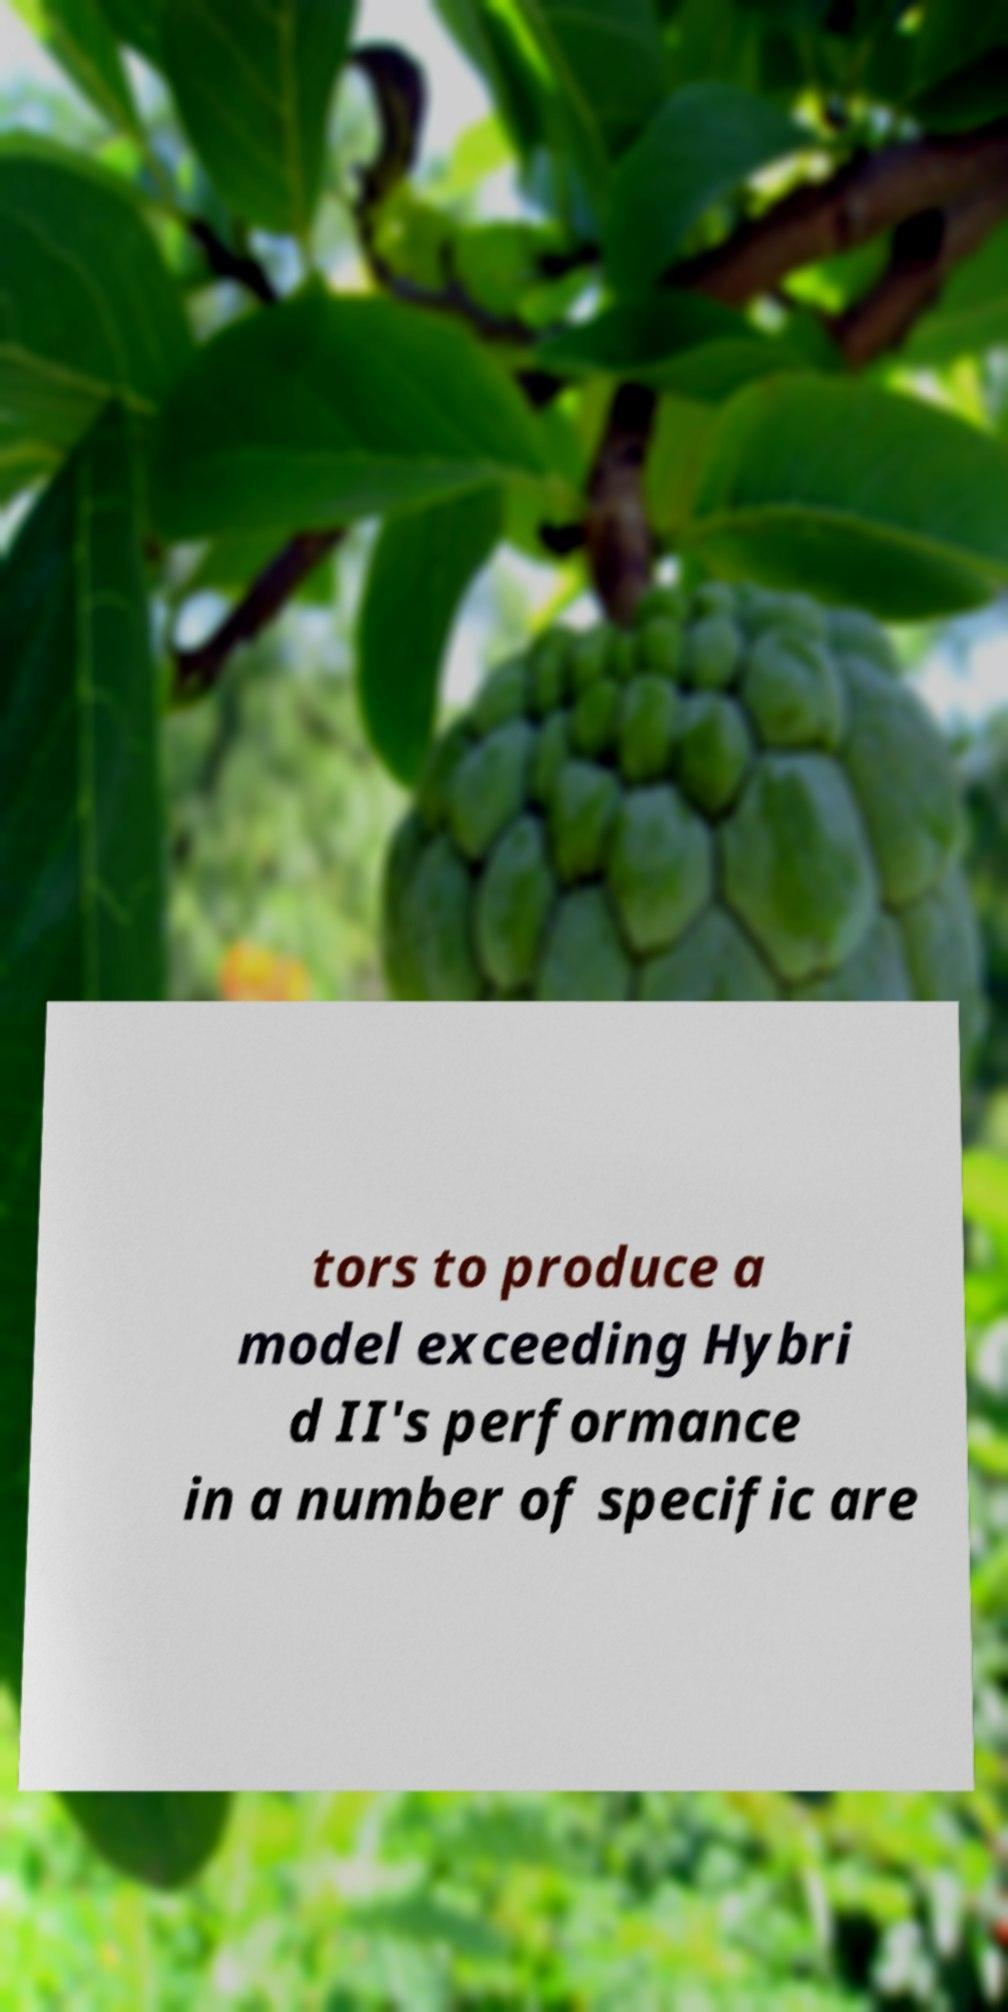For documentation purposes, I need the text within this image transcribed. Could you provide that? tors to produce a model exceeding Hybri d II's performance in a number of specific are 